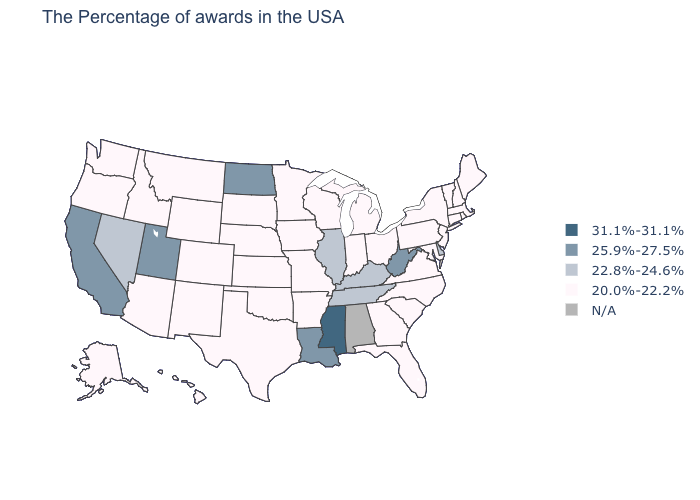What is the value of New Hampshire?
Keep it brief. 20.0%-22.2%. Does the first symbol in the legend represent the smallest category?
Keep it brief. No. Name the states that have a value in the range 31.1%-31.1%?
Answer briefly. Mississippi. What is the lowest value in the USA?
Concise answer only. 20.0%-22.2%. Name the states that have a value in the range 31.1%-31.1%?
Quick response, please. Mississippi. What is the value of Missouri?
Be succinct. 20.0%-22.2%. Does Mississippi have the highest value in the USA?
Quick response, please. Yes. What is the value of South Dakota?
Give a very brief answer. 20.0%-22.2%. Is the legend a continuous bar?
Give a very brief answer. No. What is the value of Connecticut?
Give a very brief answer. 20.0%-22.2%. Among the states that border Wisconsin , does Illinois have the lowest value?
Concise answer only. No. Name the states that have a value in the range 20.0%-22.2%?
Be succinct. Maine, Massachusetts, Rhode Island, New Hampshire, Vermont, Connecticut, New York, New Jersey, Maryland, Pennsylvania, Virginia, North Carolina, South Carolina, Ohio, Florida, Georgia, Michigan, Indiana, Wisconsin, Missouri, Arkansas, Minnesota, Iowa, Kansas, Nebraska, Oklahoma, Texas, South Dakota, Wyoming, Colorado, New Mexico, Montana, Arizona, Idaho, Washington, Oregon, Alaska, Hawaii. What is the highest value in the West ?
Concise answer only. 25.9%-27.5%. 